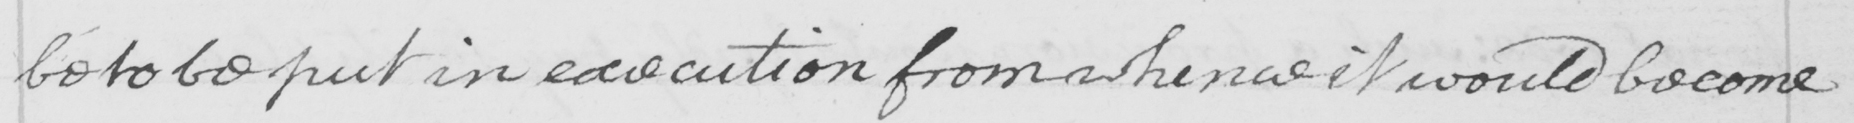Please provide the text content of this handwritten line. be to be put in execution from whence it would become 